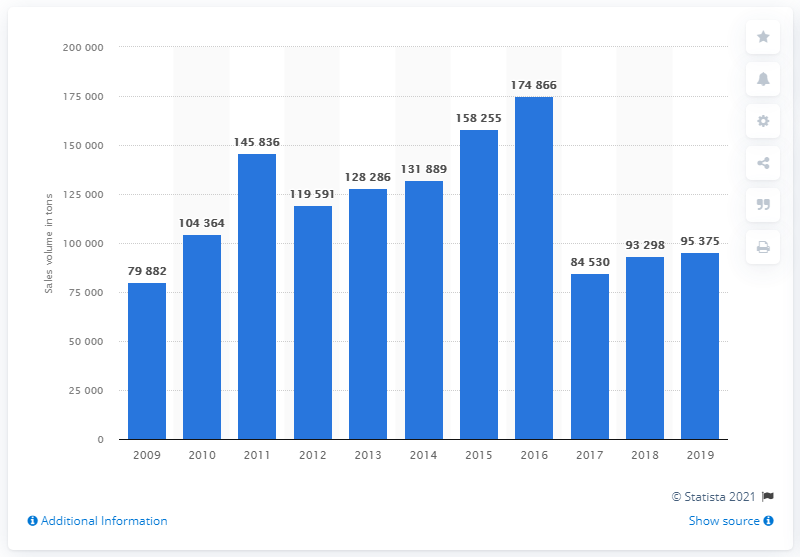Draw attention to some important aspects in this diagram. In 2019, the sales volume of whey was 95,375 units. In the year 2009, the total manufacturing sales volume for whey in the UK reached a significant milestone. 